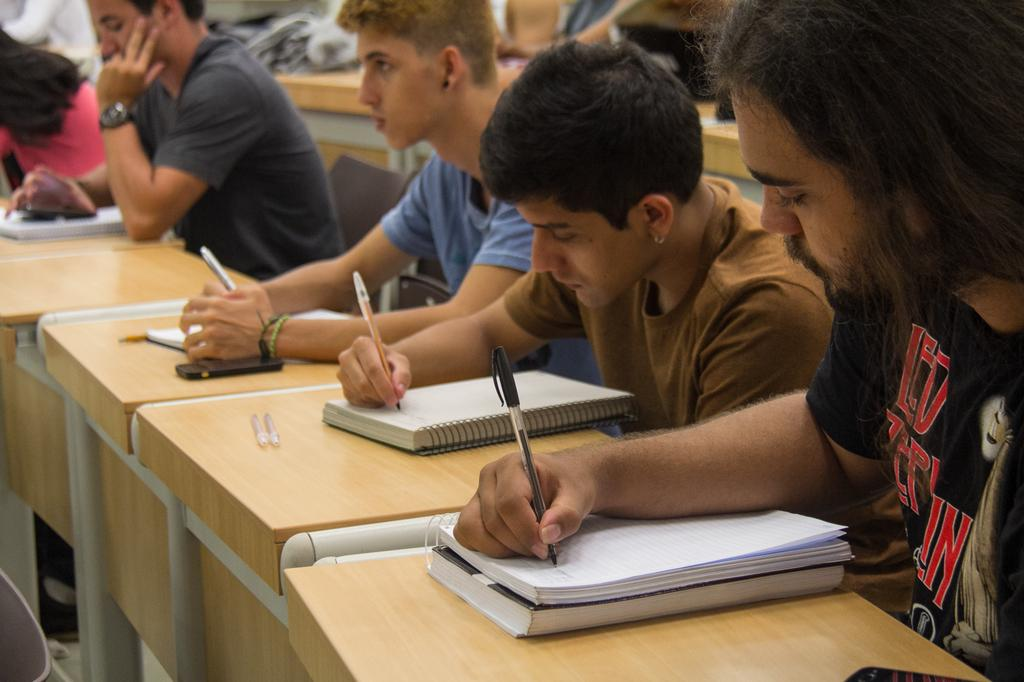<image>
Share a concise interpretation of the image provided. People in a class hold pens and write in notebooks, one of the men wears a Led Zeplin shirt. 